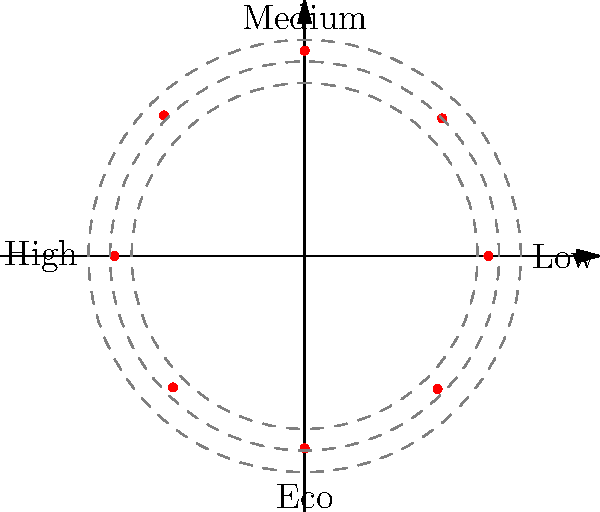The polar plot above represents the energy efficiency of a vacuum cleaner model at different power settings. Each point on the plot corresponds to a specific power setting, with the angle representing the setting and the distance from the center indicating the efficiency percentage. Which power setting achieves the highest energy efficiency? To determine the power setting with the highest energy efficiency, we need to analyze the polar plot:

1. The plot shows 8 data points, each representing a different power setting.
2. The distance from the center indicates the efficiency percentage.
3. The angles represent different power settings:
   - 0° (right): Low
   - 90° (top): Medium
   - 180° (left): High
   - 270° (bottom): Eco
   (Intermediate angles represent transitional settings)

4. Examining each point:
   - 0° (Low): ~85% efficiency
   - 45°: ~90% efficiency
   - 90° (Medium): ~95% efficiency
   - 135°: ~92% efficiency
   - 180° (High): ~88% efficiency
   - 225°: ~86% efficiency
   - 270° (Eco): ~89% efficiency
   - 315°: ~87% efficiency

5. The point furthest from the center is at 90°, corresponding to the Medium power setting.

Therefore, the Medium power setting achieves the highest energy efficiency of approximately 95%.
Answer: Medium power setting 